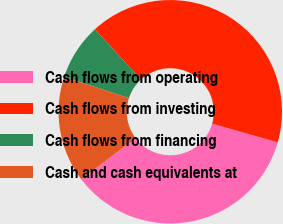Convert chart to OTSL. <chart><loc_0><loc_0><loc_500><loc_500><pie_chart><fcel>Cash flows from operating<fcel>Cash flows from investing<fcel>Cash flows from financing<fcel>Cash and cash equivalents at<nl><fcel>35.24%<fcel>41.2%<fcel>8.16%<fcel>15.4%<nl></chart> 